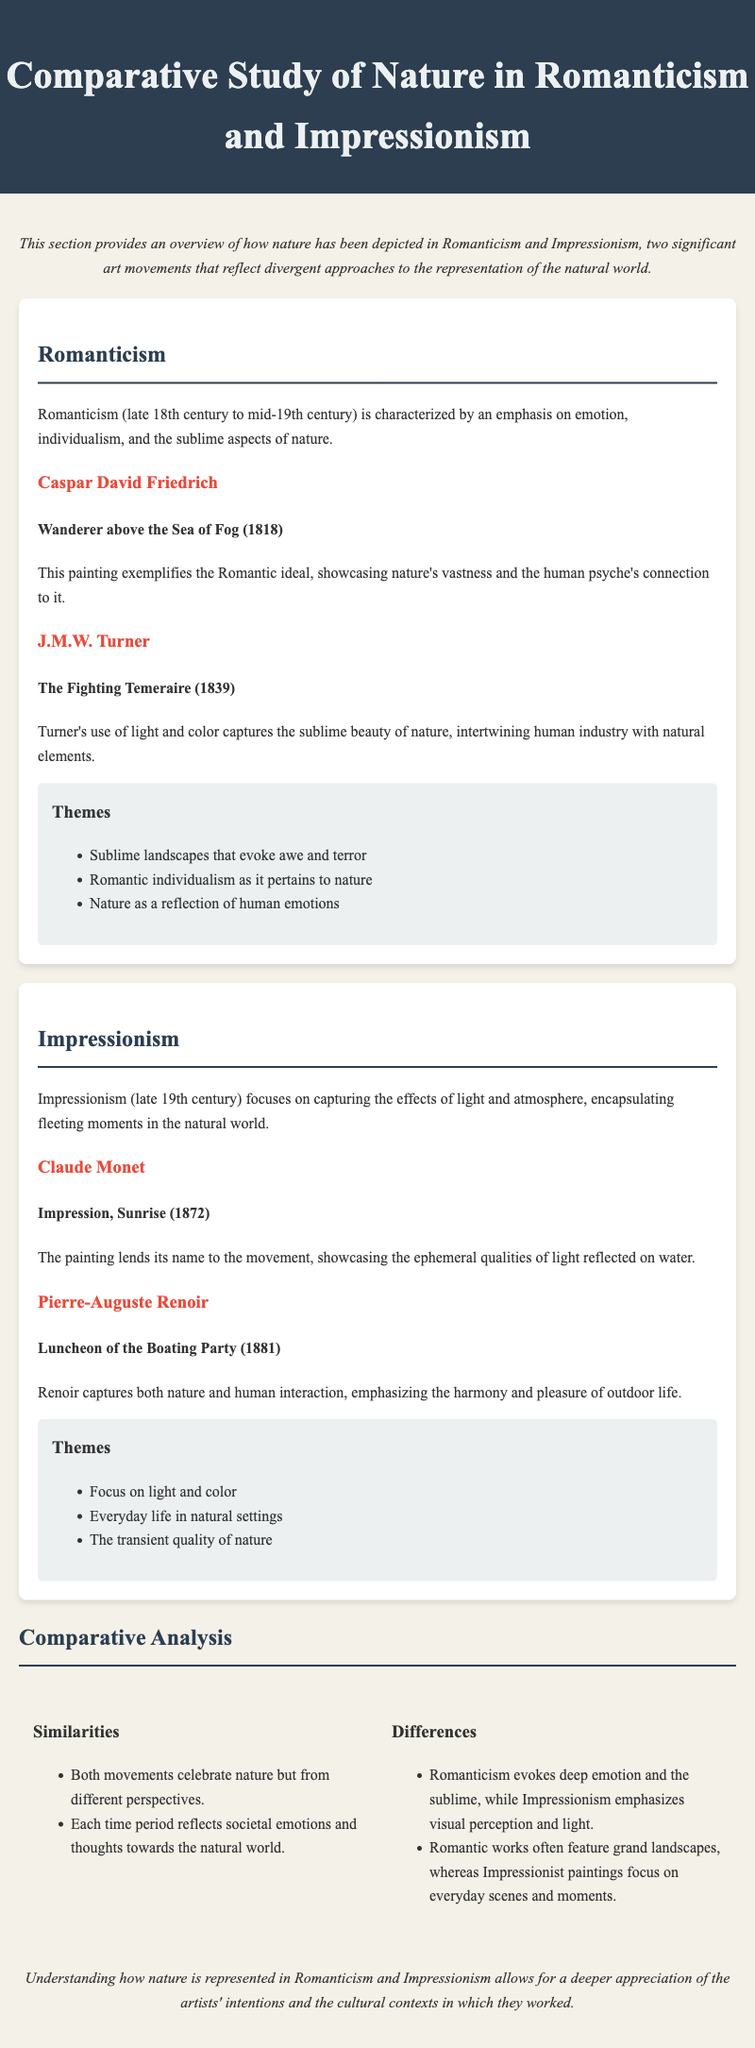What are the two art movements discussed? The document discusses the art movements of Romanticism and Impressionism.
Answer: Romanticism and Impressionism Who painted "Wanderer above the Sea of Fog"? This information is found in the Romanticism section, where Caspar David Friedrich is mentioned as the artist of this painting.
Answer: Caspar David Friedrich What year was "The Fighting Temeraire" created? The year of the painting is specified in the description of J.M.W. Turner’s work within the Romanticism section.
Answer: 1839 Which artist is associated with "Impression, Sunrise"? Claude Monet is identified as the artist of "Impression, Sunrise" in the Impressionism section.
Answer: Claude Monet What theme is highlighted in Impressionism? The document lists several themes within the Impressionism section, mentioning the focus on light and color specifically.
Answer: Focus on light and color How do Romanticism and Impressionism both celebrate nature? Both movements celebrate nature but from different perspectives, as noted in the comparative analysis.
Answer: Different perspectives What aspect does Romanticism emphasize in nature representation? The document states that Romanticism evokes deep emotion and the sublime in nature representation.
Answer: Deep emotion and the sublime What common element exists between the two movements regarding societal reflections? Both movements reflect societal emotions and thoughts towards the natural world according to the analysis section.
Answer: Societal emotions and thoughts What is the primary focus of Impressionist paintings? The focus of Impressionist paintings is outlined as capturing everyday life in natural settings.
Answer: Everyday life in natural settings 